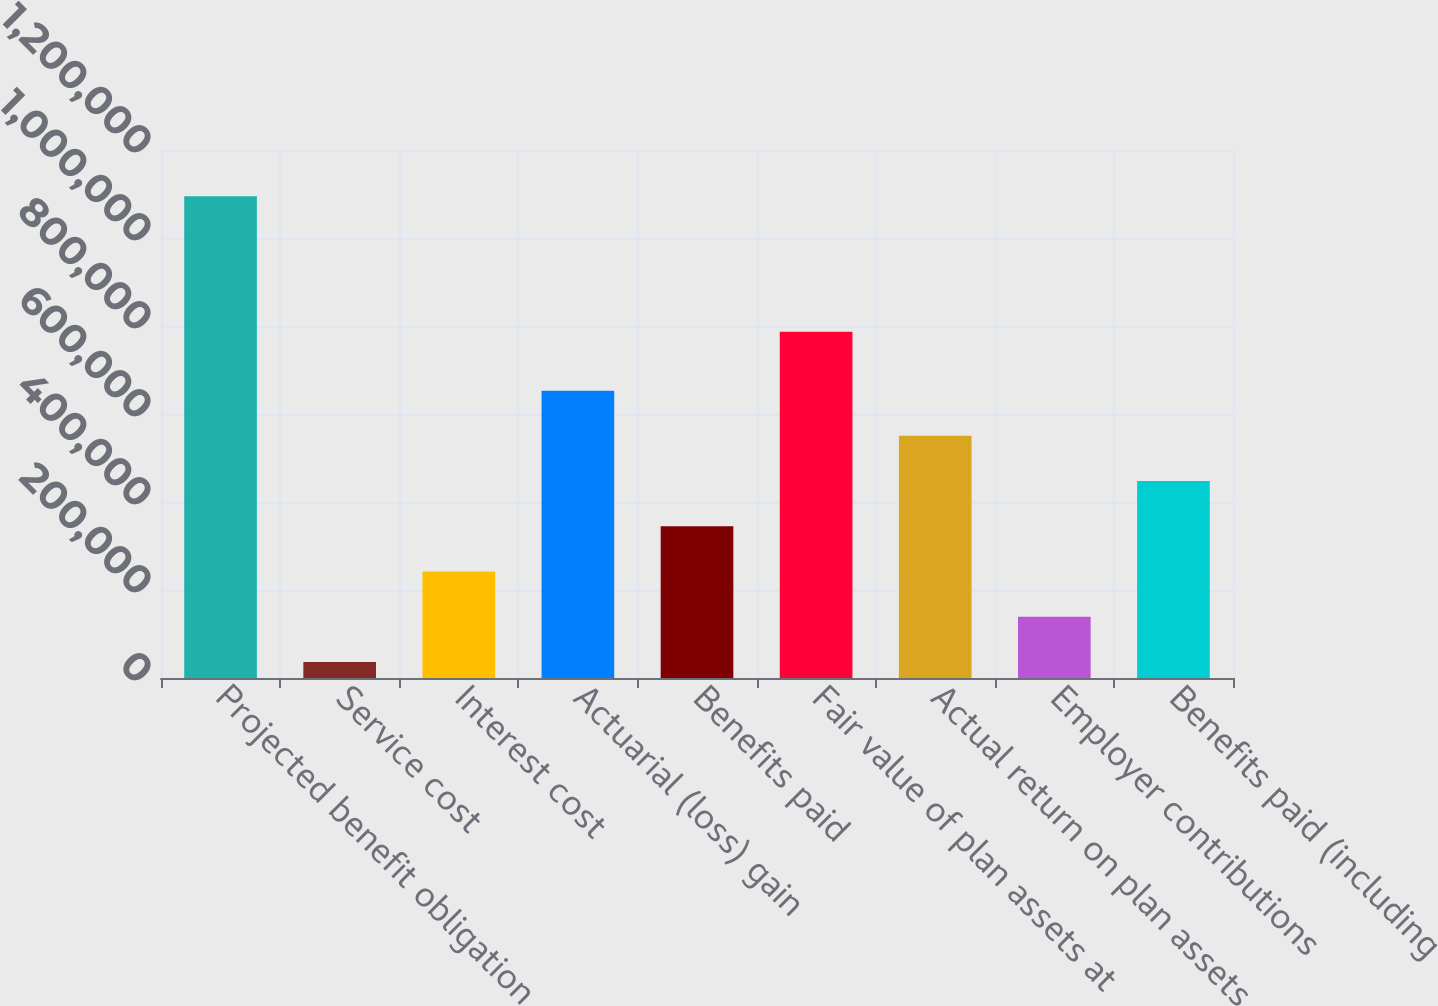Convert chart to OTSL. <chart><loc_0><loc_0><loc_500><loc_500><bar_chart><fcel>Projected benefit obligation<fcel>Service cost<fcel>Interest cost<fcel>Actuarial (loss) gain<fcel>Benefits paid<fcel>Fair value of plan assets at<fcel>Actual return on plan assets<fcel>Employer contributions<fcel>Benefits paid (including<nl><fcel>1.09498e+06<fcel>36609<fcel>242096<fcel>653069<fcel>344839<fcel>786750<fcel>550326<fcel>139352<fcel>447582<nl></chart> 